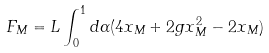Convert formula to latex. <formula><loc_0><loc_0><loc_500><loc_500>F _ { M } = L \int _ { 0 } ^ { 1 } d \alpha ( 4 x _ { M } + 2 g x _ { M } ^ { 2 } - 2 x _ { M } )</formula> 